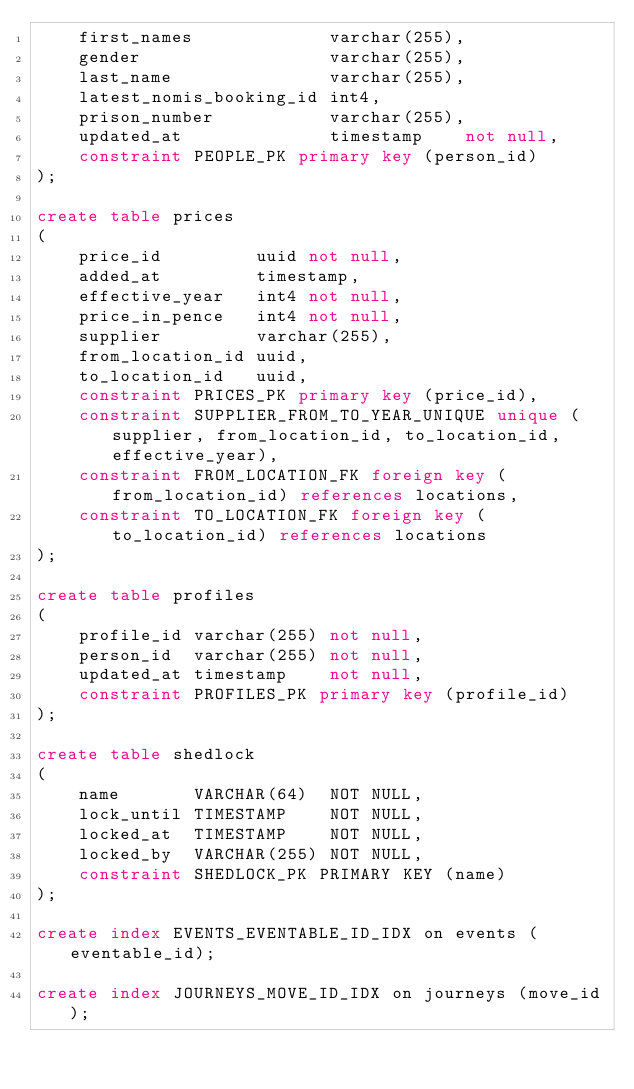<code> <loc_0><loc_0><loc_500><loc_500><_SQL_>    first_names             varchar(255),
    gender                  varchar(255),
    last_name               varchar(255),
    latest_nomis_booking_id int4,
    prison_number           varchar(255),
    updated_at              timestamp    not null,
    constraint PEOPLE_PK primary key (person_id)
);

create table prices
(
    price_id         uuid not null,
    added_at         timestamp,
    effective_year   int4 not null,
    price_in_pence   int4 not null,
    supplier         varchar(255),
    from_location_id uuid,
    to_location_id   uuid,
    constraint PRICES_PK primary key (price_id),
    constraint SUPPLIER_FROM_TO_YEAR_UNIQUE unique (supplier, from_location_id, to_location_id, effective_year),
    constraint FROM_LOCATION_FK foreign key (from_location_id) references locations,
    constraint TO_LOCATION_FK foreign key (to_location_id) references locations
);

create table profiles
(
    profile_id varchar(255) not null,
    person_id  varchar(255) not null,
    updated_at timestamp    not null,
    constraint PROFILES_PK primary key (profile_id)
);

create table shedlock
(
    name       VARCHAR(64)  NOT NULL,
    lock_until TIMESTAMP    NOT NULL,
    locked_at  TIMESTAMP    NOT NULL,
    locked_by  VARCHAR(255) NOT NULL,
    constraint SHEDLOCK_PK PRIMARY KEY (name)
);

create index EVENTS_EVENTABLE_ID_IDX on events (eventable_id);

create index JOURNEYS_MOVE_ID_IDX on journeys (move_id);
</code> 